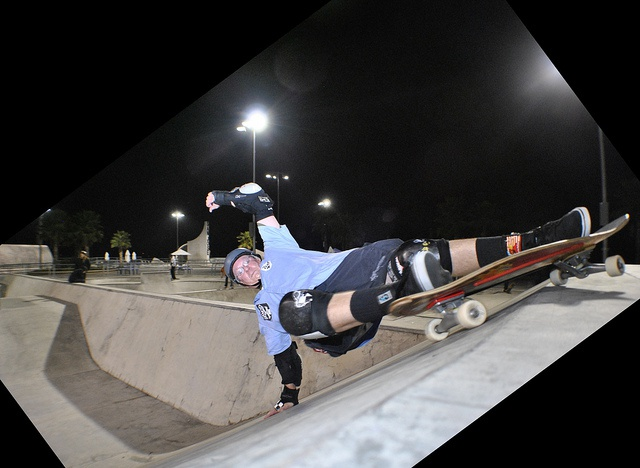Describe the objects in this image and their specific colors. I can see people in black, gray, lightblue, and lavender tones, skateboard in black, gray, maroon, and darkgray tones, people in black, olive, maroon, and gray tones, people in black, darkgray, and gray tones, and people in black, gray, and maroon tones in this image. 